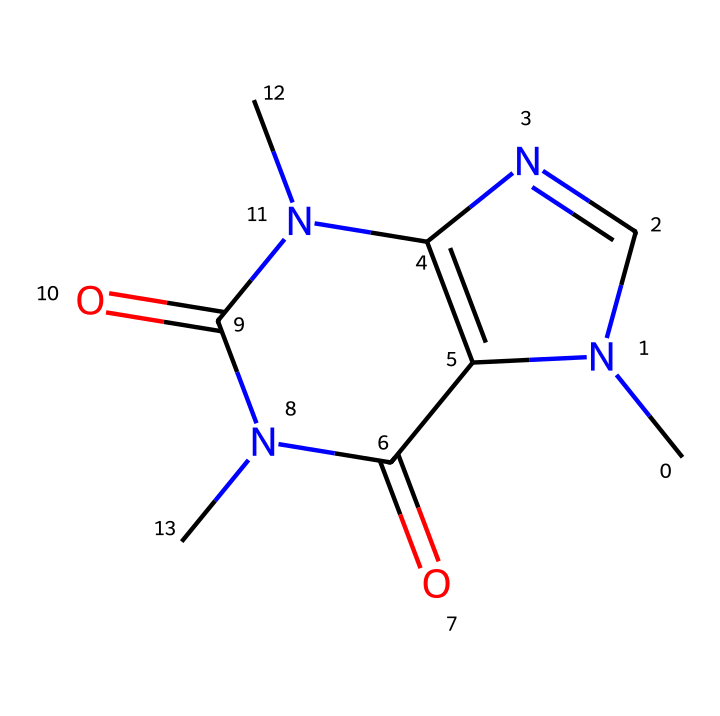What is the molecular formula of caffeine? To determine the molecular formula, we can count the number of each type of atom present in the SMILES representation. From the structure, we identify that there are 8 carbon (C) atoms, 10 hydrogen (H) atoms, 4 nitrogen (N) atoms, and 2 oxygen (O) atoms. Therefore, the molecular formula is C8H10N4O2.
Answer: C8H10N4O2 How many nitrogen atoms are in caffeine? A close examination of the SMILES representation shows there are four nitrogen (N) atoms present. Each nitrogen is indicated in the structure, confirming the total count is four.
Answer: 4 What type of chemical is caffeine classified as? Caffeine is classified as an alkaloid, which is a group of naturally occurring organic compounds that mostly contain basic nitrogen atoms. The presence of multiple nitrogen atoms highlights its classification as an alkaloid.
Answer: alkaloid What is the number of rings in the caffeine structure? By analyzing the structure represented in SMILES, we can count the rings formed. There are two fused rings (indicated from N1 and N2) in the caffeine molecule, making it a bicyclic compound.
Answer: 2 Does caffeine have any double bonds? Yes, the presence of the carbonyl groups (C=O) suggests that there are carbon atoms involved in double bonds. Confirming the chemical structure indicates at least two double bonds present.
Answer: yes What unique features does caffeine display due to its nitrogen atoms? The nitrogen atoms contribute to the basicity of caffeine, which affects its interaction with biological systems and results in its stimulating effects. The arrangement of nitrogens also stabilizes the molecule through resonance.
Answer: basicity 